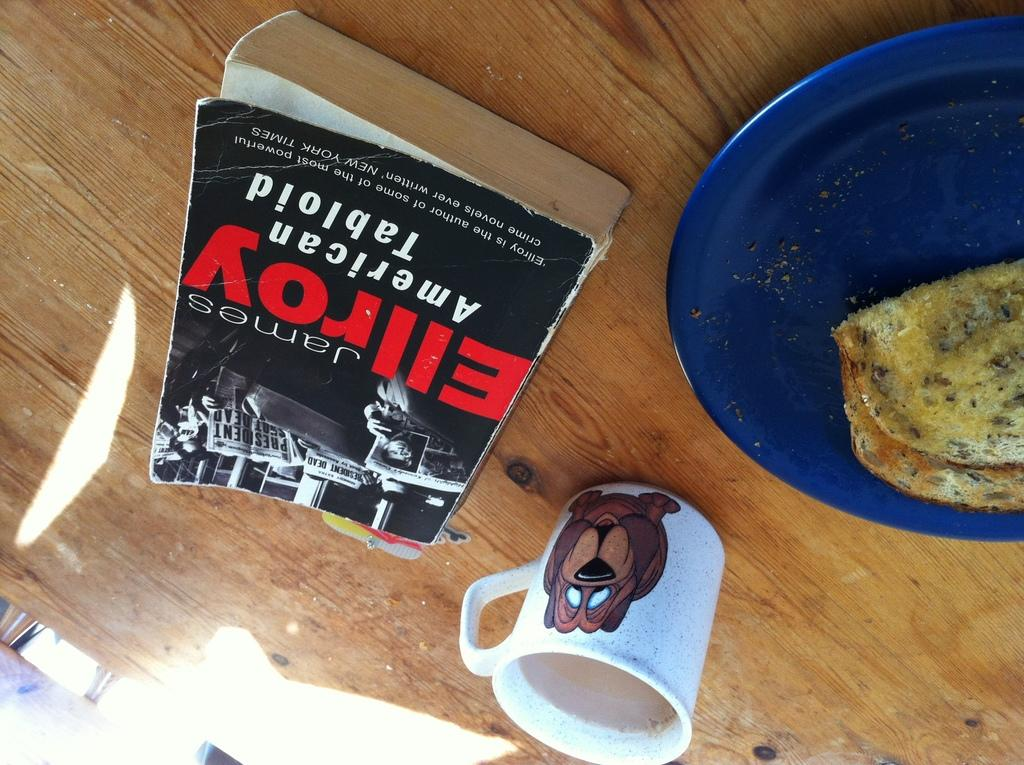<image>
Give a short and clear explanation of the subsequent image. A tattered James Ellroy paperback is titled American Tabloid. 